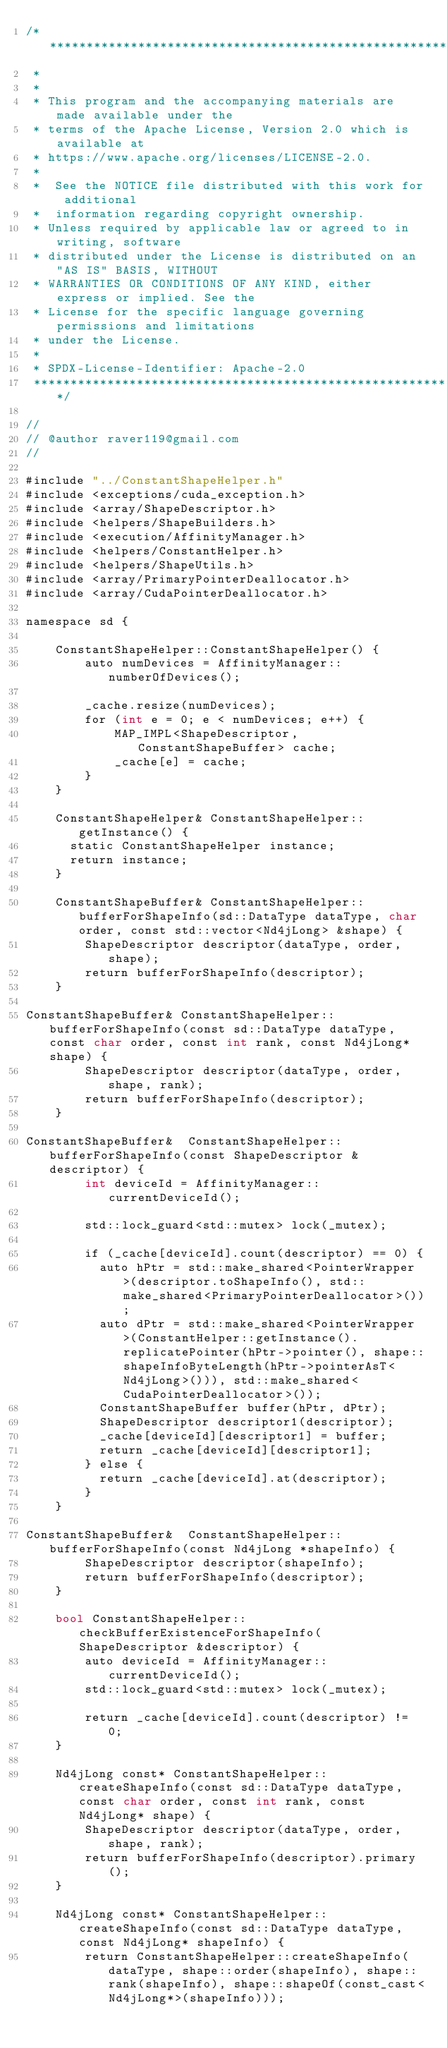Convert code to text. <code><loc_0><loc_0><loc_500><loc_500><_Cuda_>/* ******************************************************************************
 *
 *
 * This program and the accompanying materials are made available under the
 * terms of the Apache License, Version 2.0 which is available at
 * https://www.apache.org/licenses/LICENSE-2.0.
 *
 *  See the NOTICE file distributed with this work for additional
 *  information regarding copyright ownership.
 * Unless required by applicable law or agreed to in writing, software
 * distributed under the License is distributed on an "AS IS" BASIS, WITHOUT
 * WARRANTIES OR CONDITIONS OF ANY KIND, either express or implied. See the
 * License for the specific language governing permissions and limitations
 * under the License.
 *
 * SPDX-License-Identifier: Apache-2.0
 ******************************************************************************/

//
// @author raver119@gmail.com
//

#include "../ConstantShapeHelper.h"
#include <exceptions/cuda_exception.h>
#include <array/ShapeDescriptor.h>
#include <helpers/ShapeBuilders.h>
#include <execution/AffinityManager.h>
#include <helpers/ConstantHelper.h>
#include <helpers/ShapeUtils.h>
#include <array/PrimaryPointerDeallocator.h>
#include <array/CudaPointerDeallocator.h>

namespace sd {

    ConstantShapeHelper::ConstantShapeHelper() {
        auto numDevices = AffinityManager::numberOfDevices();

        _cache.resize(numDevices);
        for (int e = 0; e < numDevices; e++) {
            MAP_IMPL<ShapeDescriptor, ConstantShapeBuffer> cache;
            _cache[e] = cache;
        }
    }

    ConstantShapeHelper& ConstantShapeHelper::getInstance() {
      static ConstantShapeHelper instance;
      return instance;
    }

    ConstantShapeBuffer& ConstantShapeHelper::bufferForShapeInfo(sd::DataType dataType, char order, const std::vector<Nd4jLong> &shape) {
        ShapeDescriptor descriptor(dataType, order, shape);
        return bufferForShapeInfo(descriptor);
    }

ConstantShapeBuffer& ConstantShapeHelper::bufferForShapeInfo(const sd::DataType dataType, const char order, const int rank, const Nd4jLong* shape) {
        ShapeDescriptor descriptor(dataType, order, shape, rank);
        return bufferForShapeInfo(descriptor);
    }

ConstantShapeBuffer&  ConstantShapeHelper::bufferForShapeInfo(const ShapeDescriptor &descriptor) {
        int deviceId = AffinityManager::currentDeviceId();

        std::lock_guard<std::mutex> lock(_mutex);

        if (_cache[deviceId].count(descriptor) == 0) {
          auto hPtr = std::make_shared<PointerWrapper>(descriptor.toShapeInfo(), std::make_shared<PrimaryPointerDeallocator>());
          auto dPtr = std::make_shared<PointerWrapper>(ConstantHelper::getInstance().replicatePointer(hPtr->pointer(), shape::shapeInfoByteLength(hPtr->pointerAsT<Nd4jLong>())), std::make_shared<CudaPointerDeallocator>());
          ConstantShapeBuffer buffer(hPtr, dPtr);
          ShapeDescriptor descriptor1(descriptor);
          _cache[deviceId][descriptor1] = buffer;
          return _cache[deviceId][descriptor1];
        } else {
          return _cache[deviceId].at(descriptor);
        }
    }

ConstantShapeBuffer&  ConstantShapeHelper::bufferForShapeInfo(const Nd4jLong *shapeInfo) {
        ShapeDescriptor descriptor(shapeInfo);
        return bufferForShapeInfo(descriptor);
    }

    bool ConstantShapeHelper::checkBufferExistenceForShapeInfo(ShapeDescriptor &descriptor) {
        auto deviceId = AffinityManager::currentDeviceId();
        std::lock_guard<std::mutex> lock(_mutex);

        return _cache[deviceId].count(descriptor) != 0;
    }

    Nd4jLong const* ConstantShapeHelper::createShapeInfo(const sd::DataType dataType, const char order, const int rank, const Nd4jLong* shape) {
        ShapeDescriptor descriptor(dataType, order, shape, rank);
        return bufferForShapeInfo(descriptor).primary();
    }

    Nd4jLong const* ConstantShapeHelper::createShapeInfo(const sd::DataType dataType, const Nd4jLong* shapeInfo) {
        return ConstantShapeHelper::createShapeInfo(dataType, shape::order(shapeInfo), shape::rank(shapeInfo), shape::shapeOf(const_cast<Nd4jLong*>(shapeInfo)));</code> 